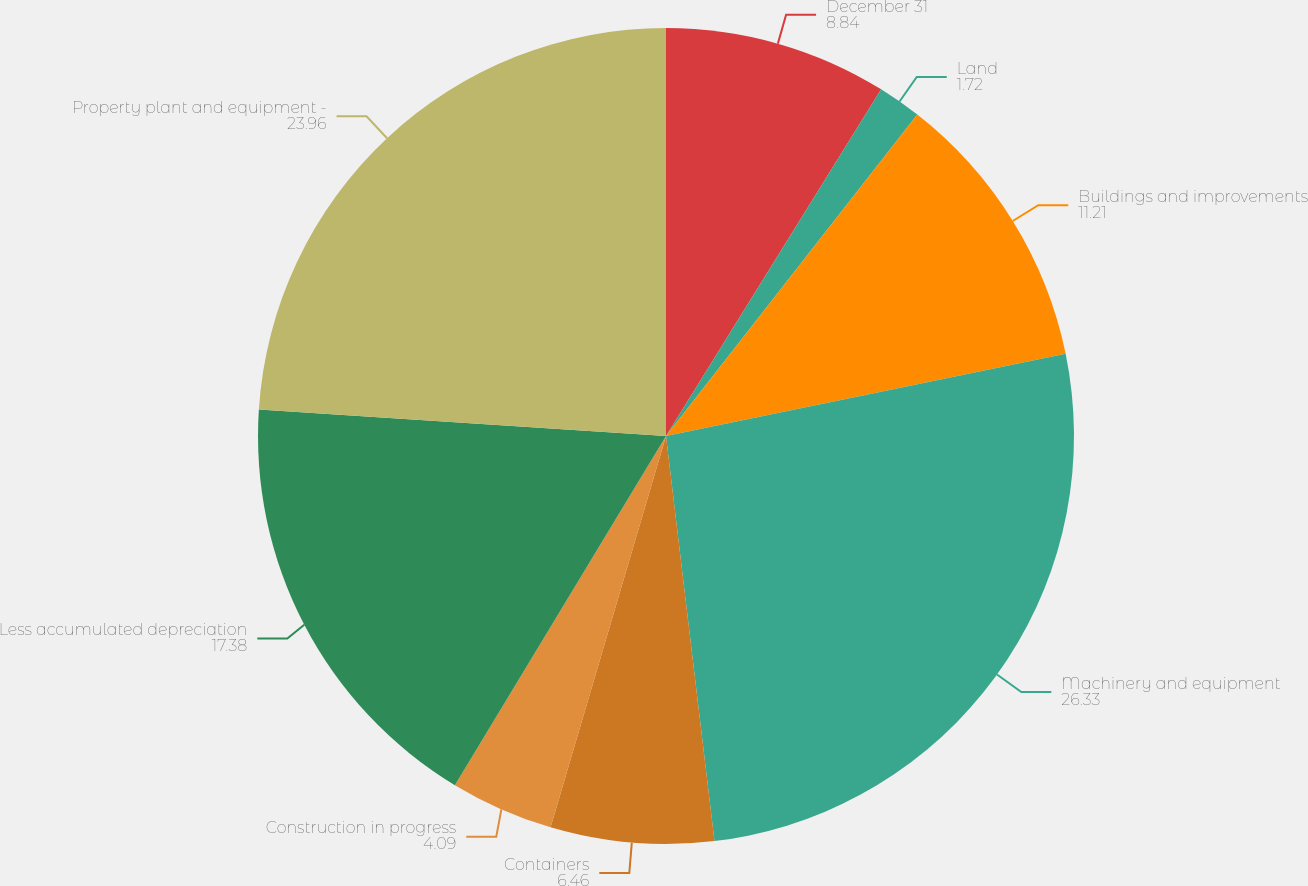Convert chart to OTSL. <chart><loc_0><loc_0><loc_500><loc_500><pie_chart><fcel>December 31<fcel>Land<fcel>Buildings and improvements<fcel>Machinery and equipment<fcel>Containers<fcel>Construction in progress<fcel>Less accumulated depreciation<fcel>Property plant and equipment -<nl><fcel>8.84%<fcel>1.72%<fcel>11.21%<fcel>26.33%<fcel>6.46%<fcel>4.09%<fcel>17.38%<fcel>23.96%<nl></chart> 